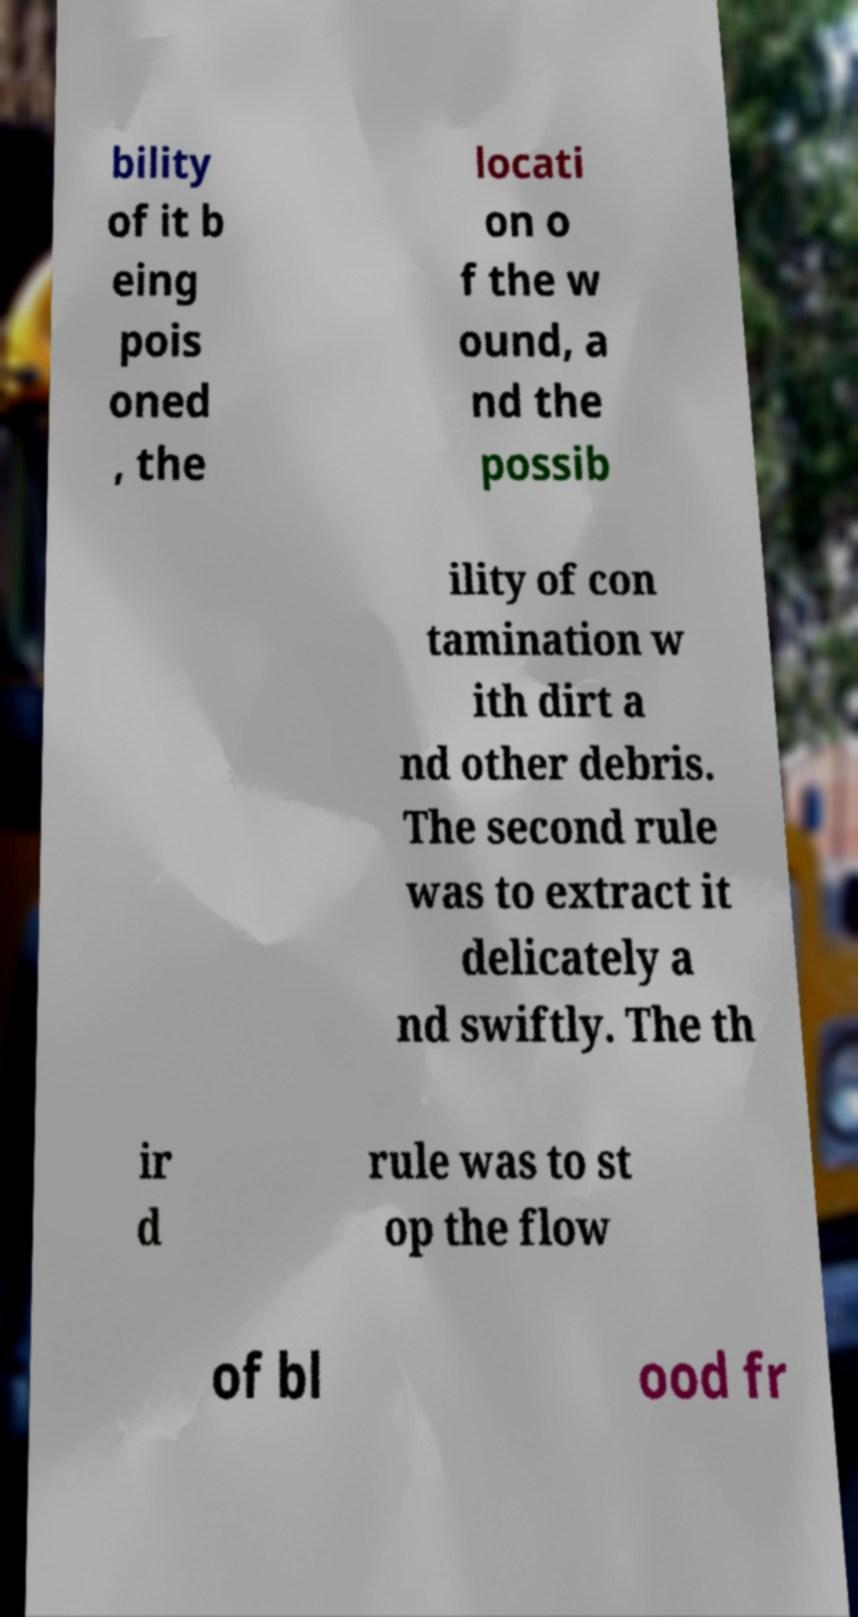Please read and relay the text visible in this image. What does it say? bility of it b eing pois oned , the locati on o f the w ound, a nd the possib ility of con tamination w ith dirt a nd other debris. The second rule was to extract it delicately a nd swiftly. The th ir d rule was to st op the flow of bl ood fr 